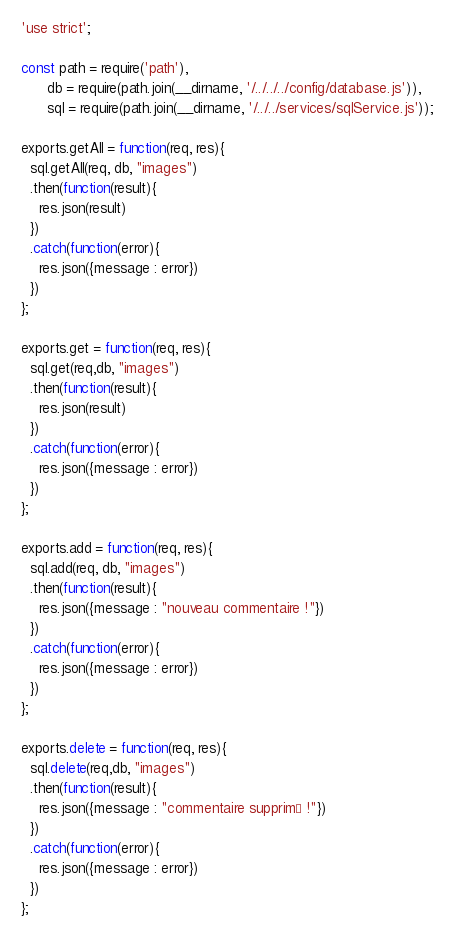Convert code to text. <code><loc_0><loc_0><loc_500><loc_500><_JavaScript_>'use strict';

const path = require('path'),
      db = require(path.join(__dirname, '/../../../config/database.js')),
      sql = require(path.join(__dirname, '/../../services/sqlService.js'));

exports.getAll = function(req, res){
  sql.getAll(req, db, "images")
  .then(function(result){
    res.json(result)
  })
  .catch(function(error){
    res.json({message : error})
  })
};

exports.get = function(req, res){
  sql.get(req,db, "images")
  .then(function(result){
    res.json(result)
  })
  .catch(function(error){
    res.json({message : error})
  })
};

exports.add = function(req, res){
  sql.add(req, db, "images")
  .then(function(result){
    res.json({message : "nouveau commentaire !"})
  })
  .catch(function(error){
    res.json({message : error})
  })
};

exports.delete = function(req, res){
  sql.delete(req,db, "images")
  .then(function(result){
    res.json({message : "commentaire supprimé !"})
  })
  .catch(function(error){
    res.json({message : error})
  })
};
</code> 